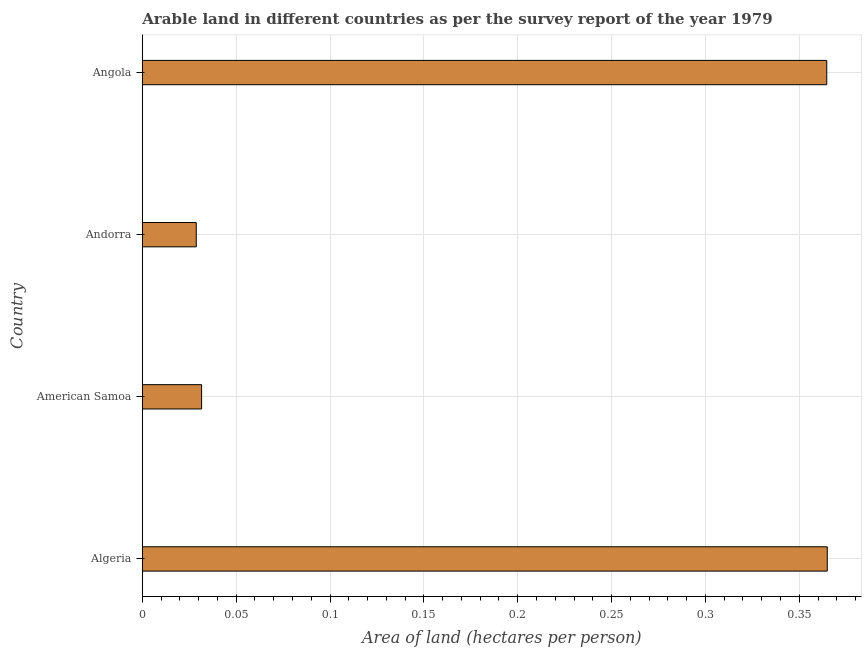Does the graph contain any zero values?
Your answer should be very brief. No. What is the title of the graph?
Provide a succinct answer. Arable land in different countries as per the survey report of the year 1979. What is the label or title of the X-axis?
Your answer should be very brief. Area of land (hectares per person). What is the label or title of the Y-axis?
Ensure brevity in your answer.  Country. What is the area of arable land in Andorra?
Offer a very short reply. 0.03. Across all countries, what is the maximum area of arable land?
Offer a very short reply. 0.36. Across all countries, what is the minimum area of arable land?
Give a very brief answer. 0.03. In which country was the area of arable land maximum?
Give a very brief answer. Algeria. In which country was the area of arable land minimum?
Your response must be concise. Andorra. What is the sum of the area of arable land?
Ensure brevity in your answer.  0.79. What is the difference between the area of arable land in Algeria and Andorra?
Offer a terse response. 0.34. What is the average area of arable land per country?
Ensure brevity in your answer.  0.2. What is the median area of arable land?
Make the answer very short. 0.2. In how many countries, is the area of arable land greater than 0.08 hectares per person?
Your response must be concise. 2. What is the ratio of the area of arable land in American Samoa to that in Andorra?
Ensure brevity in your answer.  1.1. What is the difference between the highest and the second highest area of arable land?
Keep it short and to the point. 0. Is the sum of the area of arable land in American Samoa and Andorra greater than the maximum area of arable land across all countries?
Ensure brevity in your answer.  No. What is the difference between the highest and the lowest area of arable land?
Offer a very short reply. 0.34. What is the difference between two consecutive major ticks on the X-axis?
Give a very brief answer. 0.05. What is the Area of land (hectares per person) of Algeria?
Offer a terse response. 0.36. What is the Area of land (hectares per person) in American Samoa?
Give a very brief answer. 0.03. What is the Area of land (hectares per person) in Andorra?
Provide a succinct answer. 0.03. What is the Area of land (hectares per person) in Angola?
Provide a succinct answer. 0.36. What is the difference between the Area of land (hectares per person) in Algeria and American Samoa?
Your answer should be very brief. 0.33. What is the difference between the Area of land (hectares per person) in Algeria and Andorra?
Your answer should be very brief. 0.34. What is the difference between the Area of land (hectares per person) in Algeria and Angola?
Offer a terse response. 0. What is the difference between the Area of land (hectares per person) in American Samoa and Andorra?
Ensure brevity in your answer.  0. What is the difference between the Area of land (hectares per person) in American Samoa and Angola?
Provide a short and direct response. -0.33. What is the difference between the Area of land (hectares per person) in Andorra and Angola?
Your answer should be compact. -0.34. What is the ratio of the Area of land (hectares per person) in Algeria to that in American Samoa?
Your answer should be very brief. 11.56. What is the ratio of the Area of land (hectares per person) in Algeria to that in Andorra?
Ensure brevity in your answer.  12.71. What is the ratio of the Area of land (hectares per person) in American Samoa to that in Andorra?
Offer a terse response. 1.1. What is the ratio of the Area of land (hectares per person) in American Samoa to that in Angola?
Give a very brief answer. 0.09. What is the ratio of the Area of land (hectares per person) in Andorra to that in Angola?
Keep it short and to the point. 0.08. 